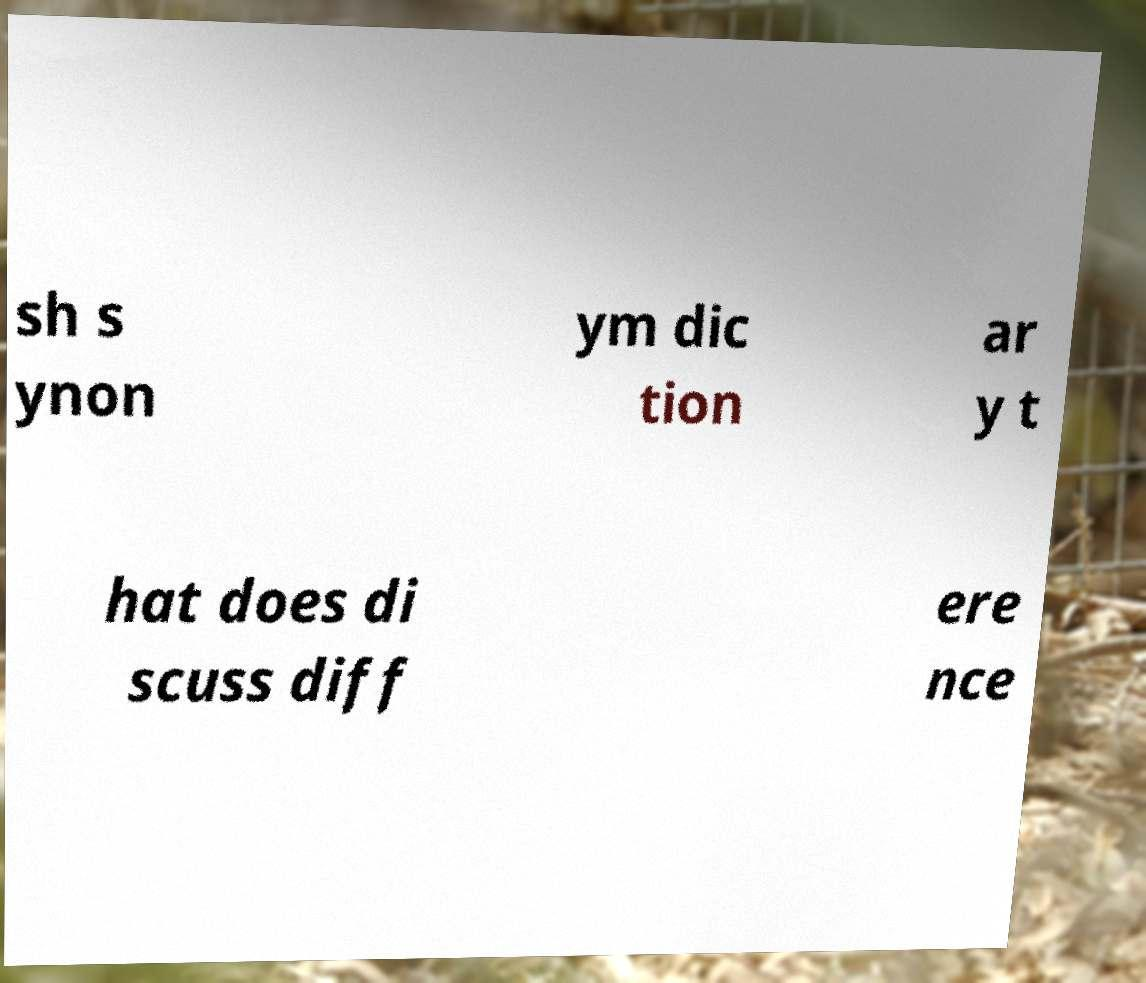I need the written content from this picture converted into text. Can you do that? sh s ynon ym dic tion ar y t hat does di scuss diff ere nce 